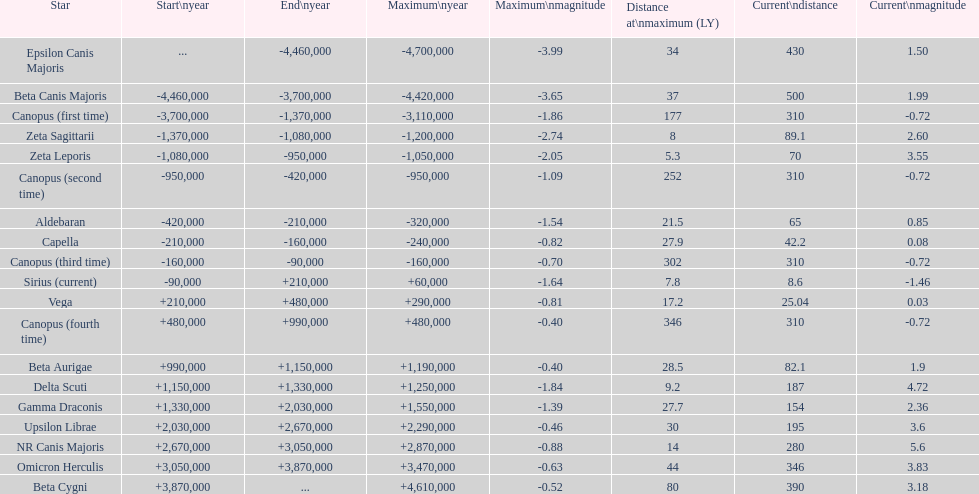How many stars have a current magnitude of at least 1.0? 11. 